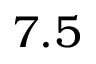<formula> <loc_0><loc_0><loc_500><loc_500>7 . 5</formula> 